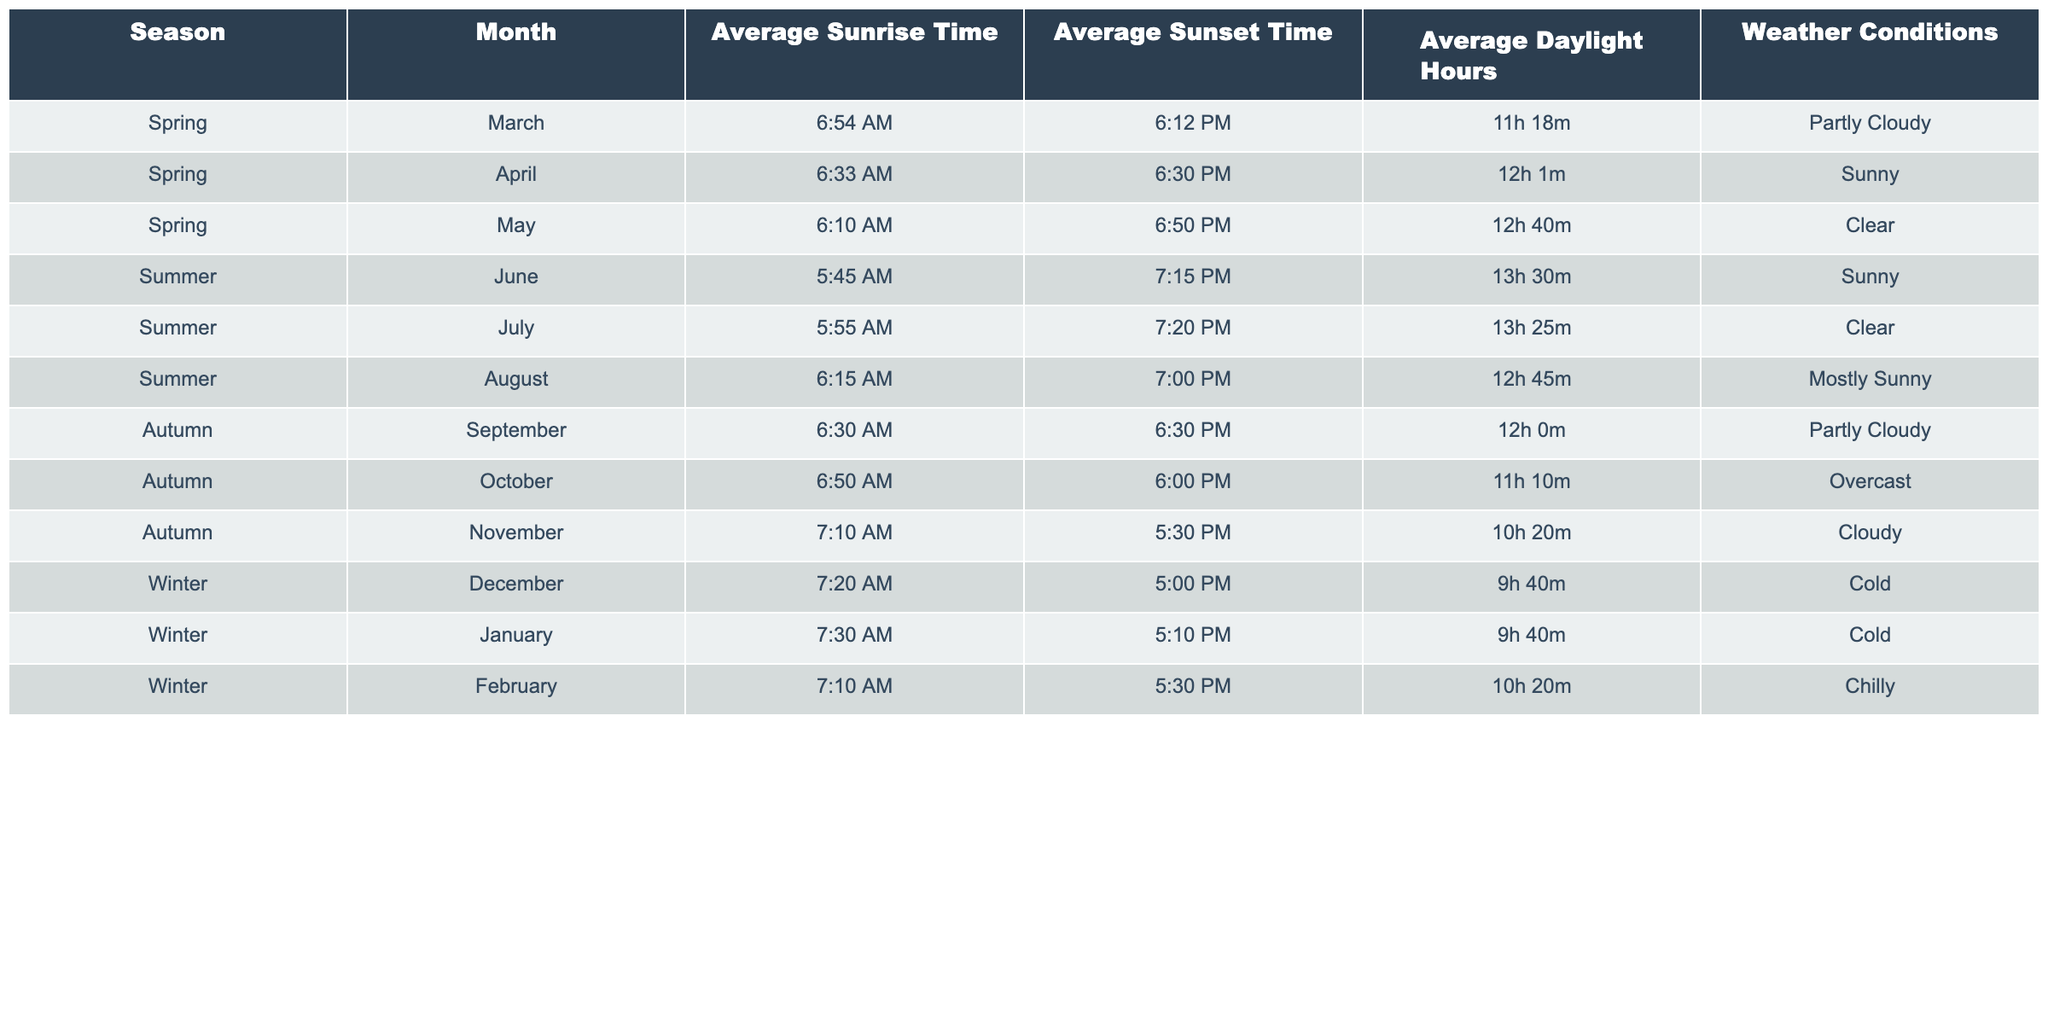What is the average sunrise time in June? The table indicates that the average sunrise time in June is 5:45 AM.
Answer: 5:45 AM How many hours of daylight does November have? According to the table, November has 10 hours and 20 minutes of daylight.
Answer: 10h 20m Which month has the longest average daylight hours? By comparing all months, June has the longest average daylight hours at 13 hours and 30 minutes.
Answer: June Do any months in spring have clear weather conditions? The table shows that May is the month in spring with clear weather conditions.
Answer: Yes How does the average sunset time vary from April to August? From the table, April's sunset is at 6:30 PM and August's is at 7:00 PM. The sunset time increases by 30 minutes from April to August, indicating longer evenings.
Answer: Increases by 30 minutes What is the average daylight hours for autumn months? The average daylight hours can be calculated by averaging the daylight hours of September (12h), October (11h 10m), and November (10h 20m). In minutes: (720 + 670 + 620) / 3 = 670 minutes, which is approximately 11h 10m.
Answer: 11h 10m Is the weather in March always partly cloudy? The table states that March has partly cloudy weather conditions, but it does not imply that March is always partly cloudy in general terms. Therefore, we cannot confirm this universally.
Answer: No Which season has the least amount of daylight hours? By reviewing the table, winter months, specifically December and January, have the least daylight hours at 9h 40m each.
Answer: Winter What is the difference in average daylight hours between the longest (June) and shortest (December) days? June has 13h 30m and December has 9h 40m. To find the difference, convert to minutes: 810 minutes in June - 580 minutes in December = 230 minutes, which is 3 hours and 50 minutes.
Answer: 3h 50m How many months in summer have sunny weather conditions? Looking at the table, June and July both have sunny weather conditions, which totals to two months.
Answer: 2 Which month has the earliest average sunrise time? The earliest average sunrise time is in May at 6:10 AM according to the table.
Answer: May 